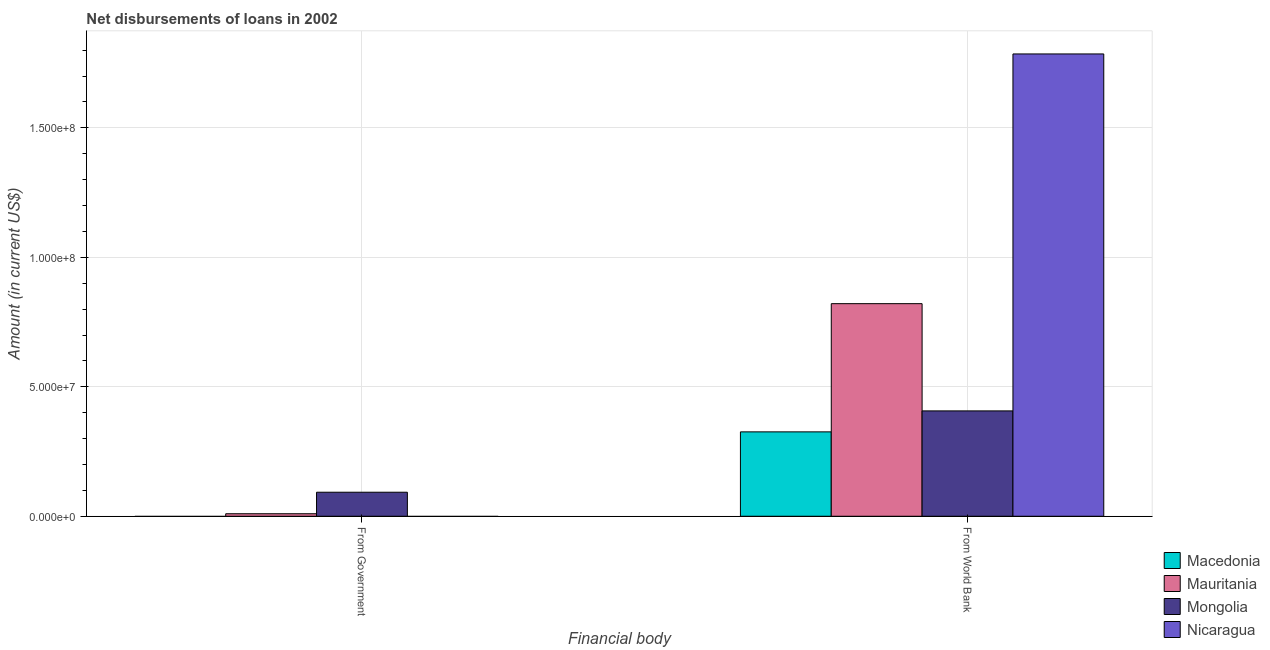How many different coloured bars are there?
Your response must be concise. 4. How many groups of bars are there?
Your answer should be very brief. 2. How many bars are there on the 1st tick from the left?
Offer a terse response. 2. How many bars are there on the 1st tick from the right?
Offer a very short reply. 4. What is the label of the 2nd group of bars from the left?
Offer a very short reply. From World Bank. What is the net disbursements of loan from world bank in Nicaragua?
Make the answer very short. 1.79e+08. Across all countries, what is the maximum net disbursements of loan from government?
Give a very brief answer. 9.28e+06. In which country was the net disbursements of loan from government maximum?
Provide a short and direct response. Mongolia. What is the total net disbursements of loan from government in the graph?
Offer a very short reply. 1.02e+07. What is the difference between the net disbursements of loan from world bank in Mongolia and that in Nicaragua?
Offer a very short reply. -1.38e+08. What is the difference between the net disbursements of loan from government in Macedonia and the net disbursements of loan from world bank in Nicaragua?
Ensure brevity in your answer.  -1.79e+08. What is the average net disbursements of loan from government per country?
Your answer should be compact. 2.56e+06. What is the difference between the net disbursements of loan from world bank and net disbursements of loan from government in Mongolia?
Give a very brief answer. 3.14e+07. What is the ratio of the net disbursements of loan from world bank in Nicaragua to that in Mongolia?
Your response must be concise. 4.39. How many bars are there?
Your answer should be very brief. 6. Are all the bars in the graph horizontal?
Offer a very short reply. No. What is the difference between two consecutive major ticks on the Y-axis?
Offer a terse response. 5.00e+07. Are the values on the major ticks of Y-axis written in scientific E-notation?
Provide a short and direct response. Yes. Does the graph contain any zero values?
Ensure brevity in your answer.  Yes. Does the graph contain grids?
Provide a short and direct response. Yes. How are the legend labels stacked?
Provide a short and direct response. Vertical. What is the title of the graph?
Ensure brevity in your answer.  Net disbursements of loans in 2002. What is the label or title of the X-axis?
Your answer should be compact. Financial body. What is the label or title of the Y-axis?
Give a very brief answer. Amount (in current US$). What is the Amount (in current US$) of Macedonia in From Government?
Make the answer very short. 0. What is the Amount (in current US$) in Mauritania in From Government?
Keep it short and to the point. 9.69e+05. What is the Amount (in current US$) of Mongolia in From Government?
Your answer should be very brief. 9.28e+06. What is the Amount (in current US$) in Nicaragua in From Government?
Give a very brief answer. 0. What is the Amount (in current US$) of Macedonia in From World Bank?
Offer a very short reply. 3.26e+07. What is the Amount (in current US$) in Mauritania in From World Bank?
Provide a short and direct response. 8.21e+07. What is the Amount (in current US$) in Mongolia in From World Bank?
Provide a short and direct response. 4.07e+07. What is the Amount (in current US$) in Nicaragua in From World Bank?
Provide a short and direct response. 1.79e+08. Across all Financial body, what is the maximum Amount (in current US$) of Macedonia?
Your response must be concise. 3.26e+07. Across all Financial body, what is the maximum Amount (in current US$) of Mauritania?
Keep it short and to the point. 8.21e+07. Across all Financial body, what is the maximum Amount (in current US$) of Mongolia?
Offer a very short reply. 4.07e+07. Across all Financial body, what is the maximum Amount (in current US$) in Nicaragua?
Make the answer very short. 1.79e+08. Across all Financial body, what is the minimum Amount (in current US$) of Mauritania?
Offer a terse response. 9.69e+05. Across all Financial body, what is the minimum Amount (in current US$) in Mongolia?
Provide a succinct answer. 9.28e+06. Across all Financial body, what is the minimum Amount (in current US$) in Nicaragua?
Provide a succinct answer. 0. What is the total Amount (in current US$) of Macedonia in the graph?
Your answer should be compact. 3.26e+07. What is the total Amount (in current US$) of Mauritania in the graph?
Provide a succinct answer. 8.31e+07. What is the total Amount (in current US$) in Mongolia in the graph?
Ensure brevity in your answer.  5.00e+07. What is the total Amount (in current US$) in Nicaragua in the graph?
Ensure brevity in your answer.  1.79e+08. What is the difference between the Amount (in current US$) of Mauritania in From Government and that in From World Bank?
Your answer should be very brief. -8.11e+07. What is the difference between the Amount (in current US$) in Mongolia in From Government and that in From World Bank?
Offer a very short reply. -3.14e+07. What is the difference between the Amount (in current US$) of Mauritania in From Government and the Amount (in current US$) of Mongolia in From World Bank?
Give a very brief answer. -3.97e+07. What is the difference between the Amount (in current US$) in Mauritania in From Government and the Amount (in current US$) in Nicaragua in From World Bank?
Your answer should be very brief. -1.78e+08. What is the difference between the Amount (in current US$) in Mongolia in From Government and the Amount (in current US$) in Nicaragua in From World Bank?
Keep it short and to the point. -1.69e+08. What is the average Amount (in current US$) in Macedonia per Financial body?
Offer a very short reply. 1.63e+07. What is the average Amount (in current US$) in Mauritania per Financial body?
Your response must be concise. 4.15e+07. What is the average Amount (in current US$) in Mongolia per Financial body?
Your response must be concise. 2.50e+07. What is the average Amount (in current US$) of Nicaragua per Financial body?
Offer a terse response. 8.93e+07. What is the difference between the Amount (in current US$) in Mauritania and Amount (in current US$) in Mongolia in From Government?
Give a very brief answer. -8.31e+06. What is the difference between the Amount (in current US$) in Macedonia and Amount (in current US$) in Mauritania in From World Bank?
Give a very brief answer. -4.95e+07. What is the difference between the Amount (in current US$) in Macedonia and Amount (in current US$) in Mongolia in From World Bank?
Keep it short and to the point. -8.10e+06. What is the difference between the Amount (in current US$) of Macedonia and Amount (in current US$) of Nicaragua in From World Bank?
Your response must be concise. -1.46e+08. What is the difference between the Amount (in current US$) of Mauritania and Amount (in current US$) of Mongolia in From World Bank?
Your response must be concise. 4.14e+07. What is the difference between the Amount (in current US$) of Mauritania and Amount (in current US$) of Nicaragua in From World Bank?
Offer a very short reply. -9.64e+07. What is the difference between the Amount (in current US$) in Mongolia and Amount (in current US$) in Nicaragua in From World Bank?
Provide a succinct answer. -1.38e+08. What is the ratio of the Amount (in current US$) in Mauritania in From Government to that in From World Bank?
Your answer should be compact. 0.01. What is the ratio of the Amount (in current US$) in Mongolia in From Government to that in From World Bank?
Provide a succinct answer. 0.23. What is the difference between the highest and the second highest Amount (in current US$) of Mauritania?
Make the answer very short. 8.11e+07. What is the difference between the highest and the second highest Amount (in current US$) of Mongolia?
Offer a terse response. 3.14e+07. What is the difference between the highest and the lowest Amount (in current US$) in Macedonia?
Keep it short and to the point. 3.26e+07. What is the difference between the highest and the lowest Amount (in current US$) in Mauritania?
Ensure brevity in your answer.  8.11e+07. What is the difference between the highest and the lowest Amount (in current US$) in Mongolia?
Offer a terse response. 3.14e+07. What is the difference between the highest and the lowest Amount (in current US$) in Nicaragua?
Your answer should be very brief. 1.79e+08. 